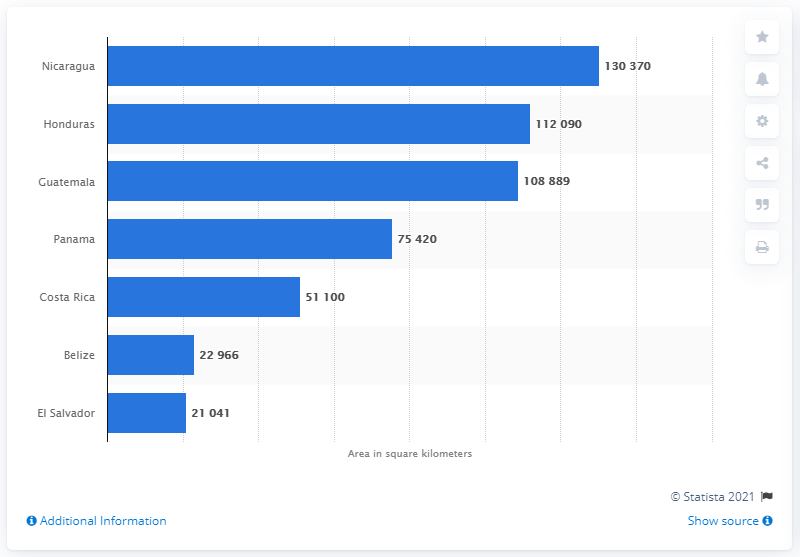Point out several critical features in this image. Nicaragua is the largest country in the subregion. The total area of Honduras is 112,090 square kilometers. 